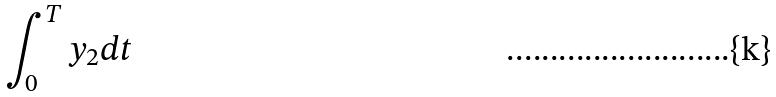<formula> <loc_0><loc_0><loc_500><loc_500>\int _ { 0 } ^ { T } y _ { 2 } d t</formula> 